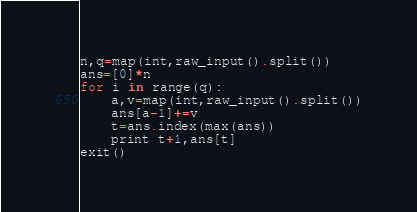Convert code to text. <code><loc_0><loc_0><loc_500><loc_500><_Python_>n,q=map(int,raw_input().split())
ans=[0]*n
for i in range(q):
    a,v=map(int,raw_input().split())
    ans[a-1]+=v
    t=ans.index(max(ans))
    print t+1,ans[t]
exit()</code> 